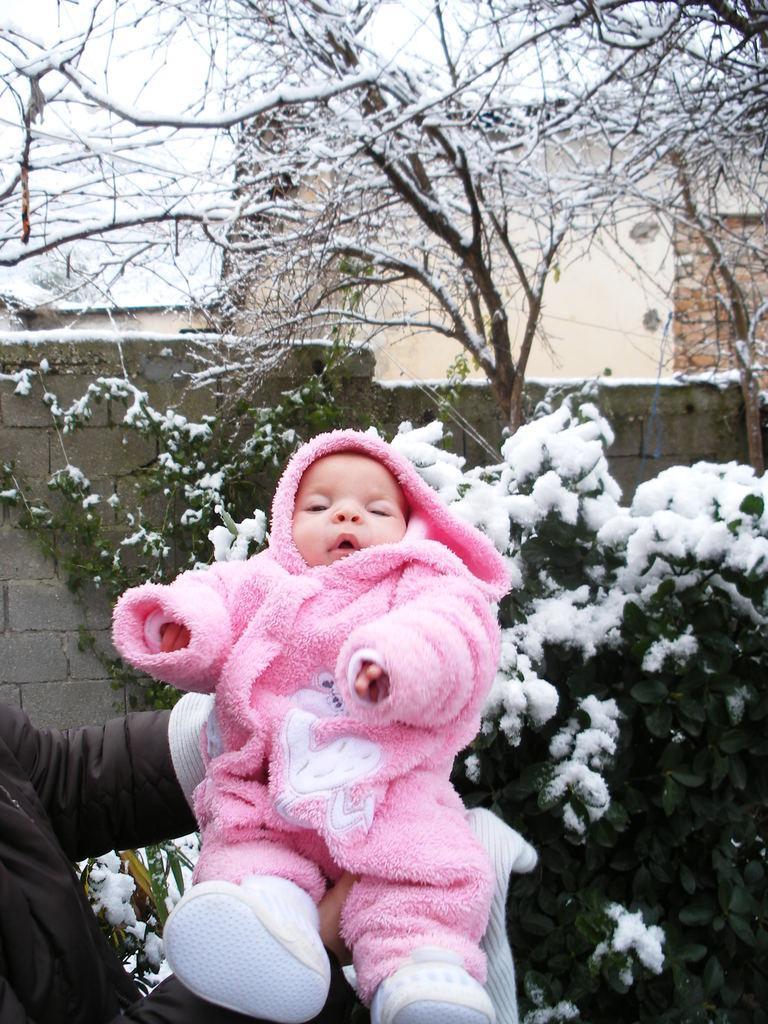In one or two sentences, can you explain what this image depicts? In this image we can see one person hands holding a baby with pink dress, one house, one wall, some trees with snow, on white towel, some snow on the ground, some plants with snow and at the top there is the sky. 